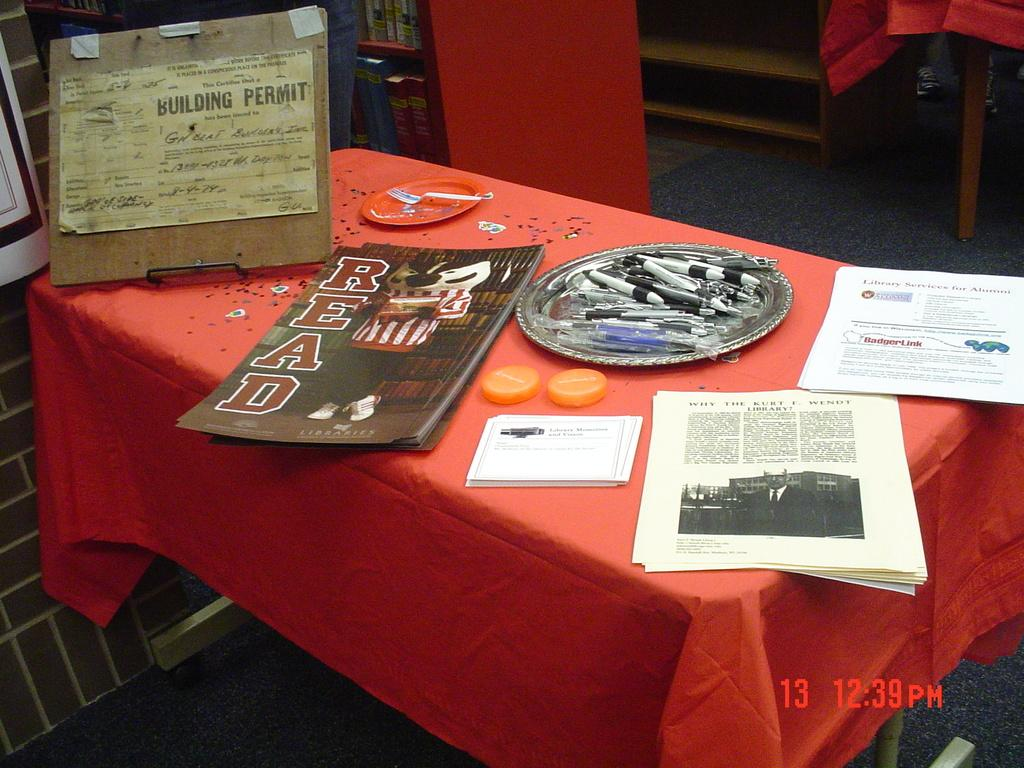<image>
Offer a succinct explanation of the picture presented. A table with a Bead magazine on it is littered with other papers. 